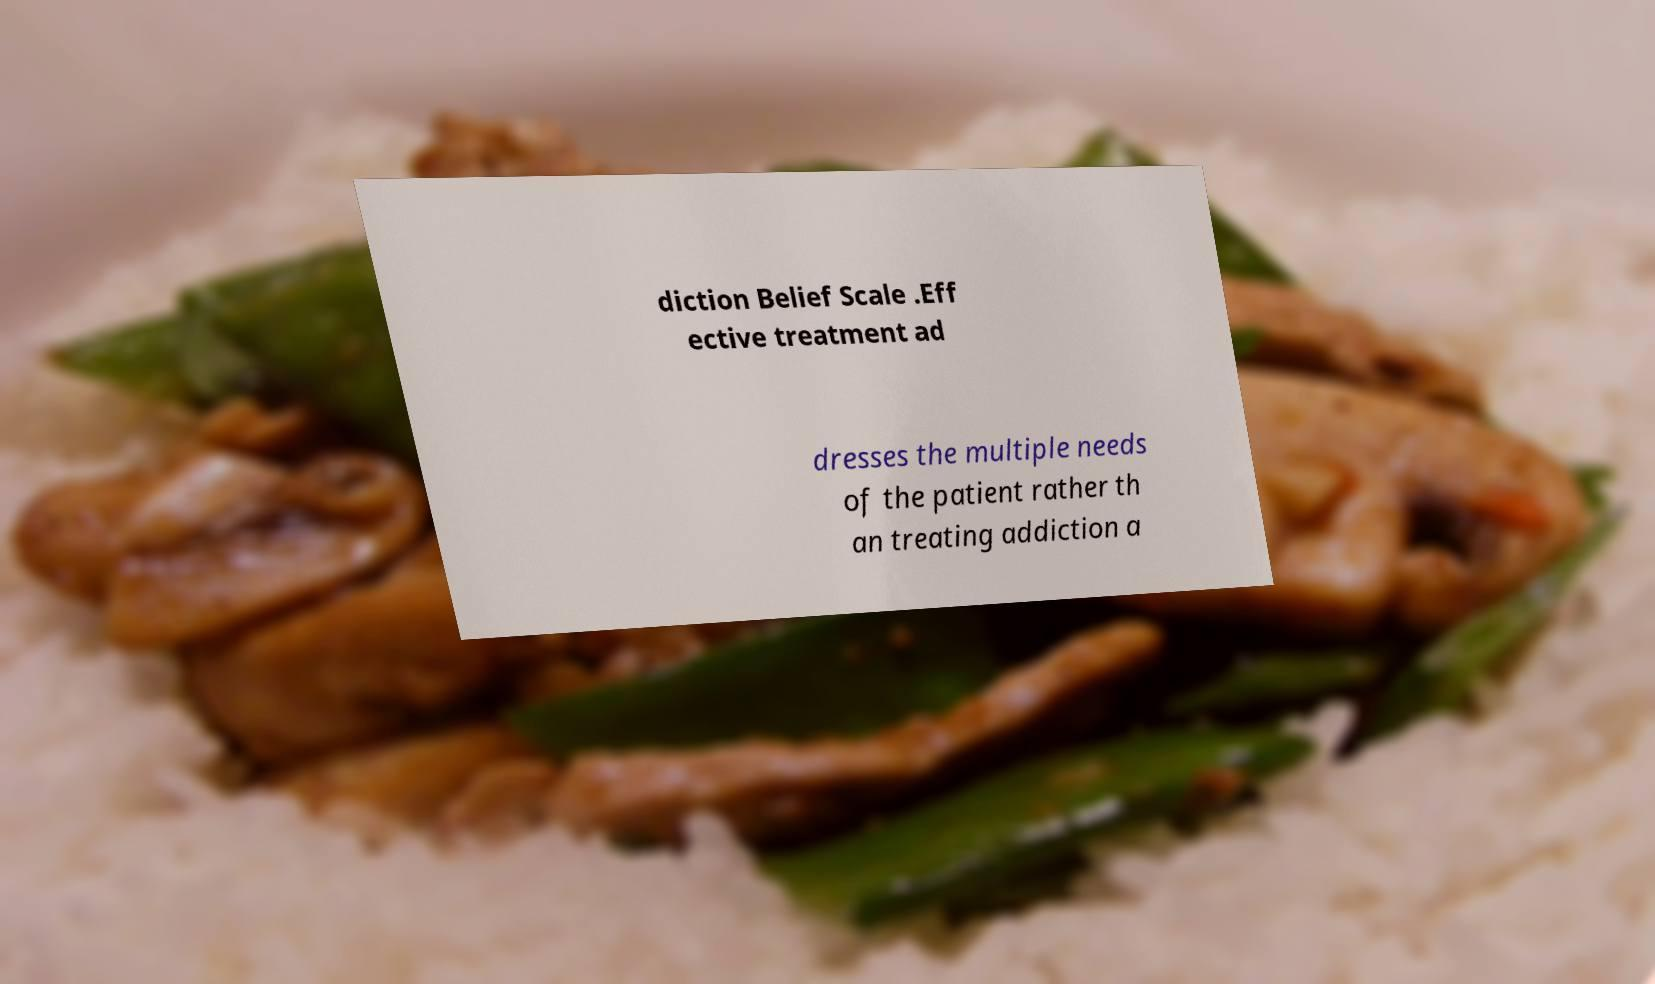Could you assist in decoding the text presented in this image and type it out clearly? diction Belief Scale .Eff ective treatment ad dresses the multiple needs of the patient rather th an treating addiction a 